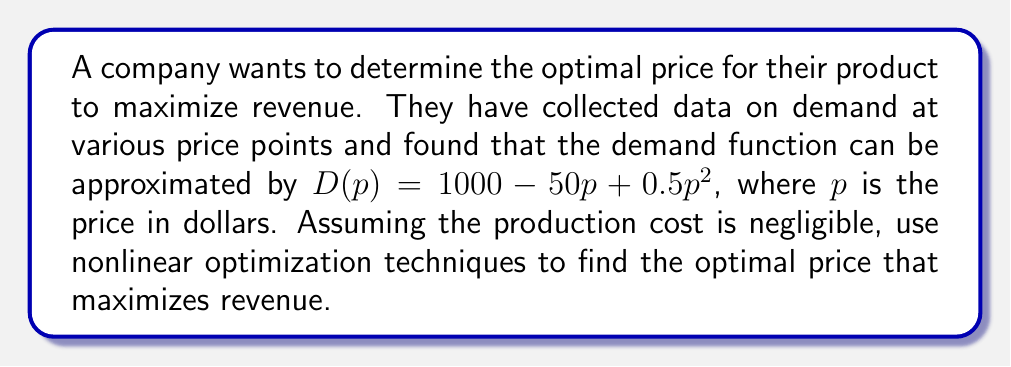What is the answer to this math problem? To solve this problem, we'll follow these steps:

1) The revenue function $R(p)$ is given by price times demand:
   $$R(p) = p \cdot D(p) = p(1000 - 50p + 0.5p^2)$$

2) Expand the revenue function:
   $$R(p) = 1000p - 50p^2 + 0.5p^3$$

3) To find the maximum, we need to find where the derivative of $R(p)$ equals zero:
   $$\frac{dR}{dp} = 1000 - 100p + 1.5p^2$$

4) Set the derivative to zero and solve:
   $$1000 - 100p + 1.5p^2 = 0$$
   $$1.5p^2 - 100p + 1000 = 0$$

5) This is a quadratic equation. We can solve it using the quadratic formula:
   $$p = \frac{-b \pm \sqrt{b^2 - 4ac}}{2a}$$
   where $a = 1.5$, $b = -100$, and $c = 1000$

6) Plugging in the values:
   $$p = \frac{100 \pm \sqrt{10000 - 6000}}{3} = \frac{100 \pm \sqrt{4000}}{3} = \frac{100 \pm 20\sqrt{10}}{3}$$

7) This gives us two solutions:
   $$p_1 = \frac{100 + 20\sqrt{10}}{3} \approx 54.35$$
   $$p_2 = \frac{100 - 20\sqrt{10}}{3} \approx 12.31$$

8) To determine which one is the maximum, we can check the second derivative:
   $$\frac{d^2R}{dp^2} = -100 + 3p$$
   At $p_1$, this is positive, indicating a local minimum.
   At $p_2$, this is negative, indicating a local maximum.

Therefore, the optimal price that maximizes revenue is approximately $12.31.
Answer: $12.31 